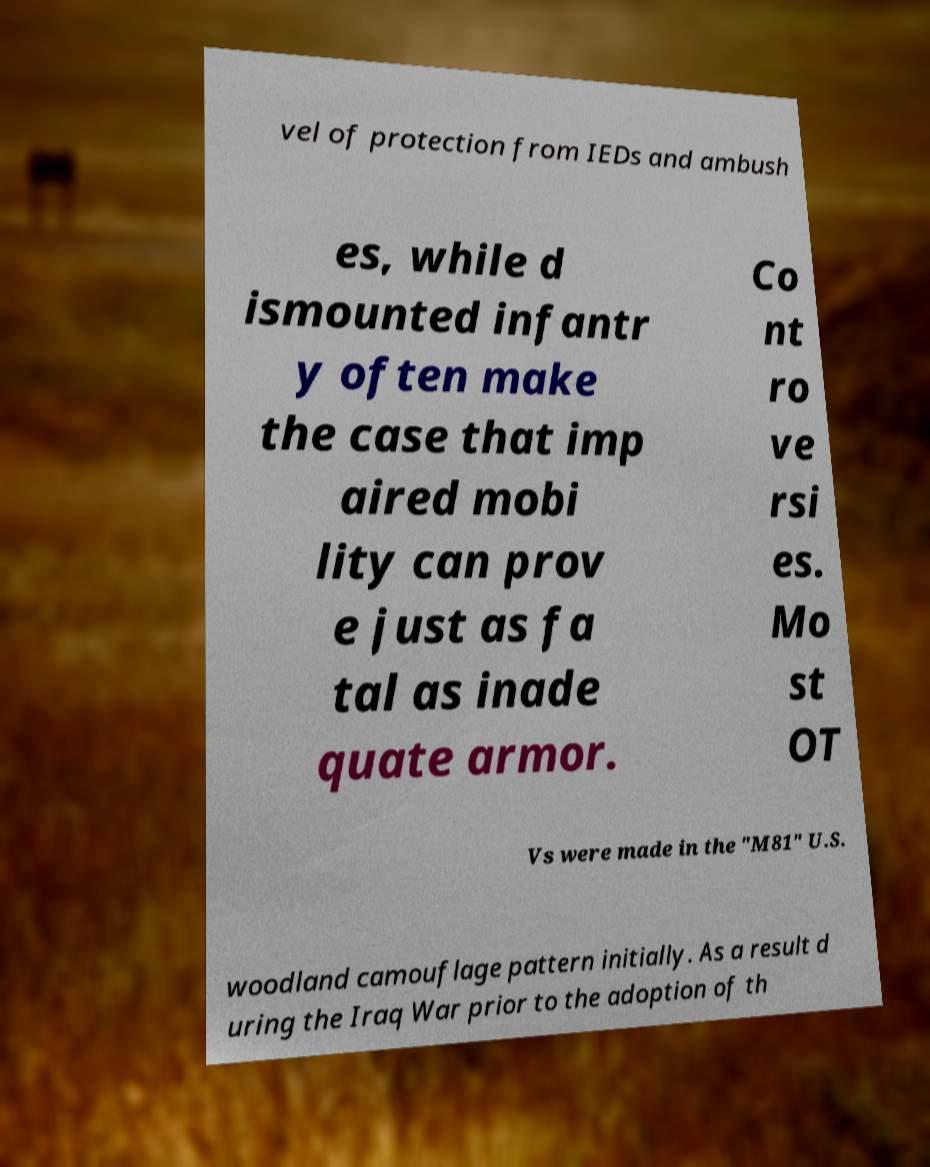I need the written content from this picture converted into text. Can you do that? vel of protection from IEDs and ambush es, while d ismounted infantr y often make the case that imp aired mobi lity can prov e just as fa tal as inade quate armor. Co nt ro ve rsi es. Mo st OT Vs were made in the "M81" U.S. woodland camouflage pattern initially. As a result d uring the Iraq War prior to the adoption of th 